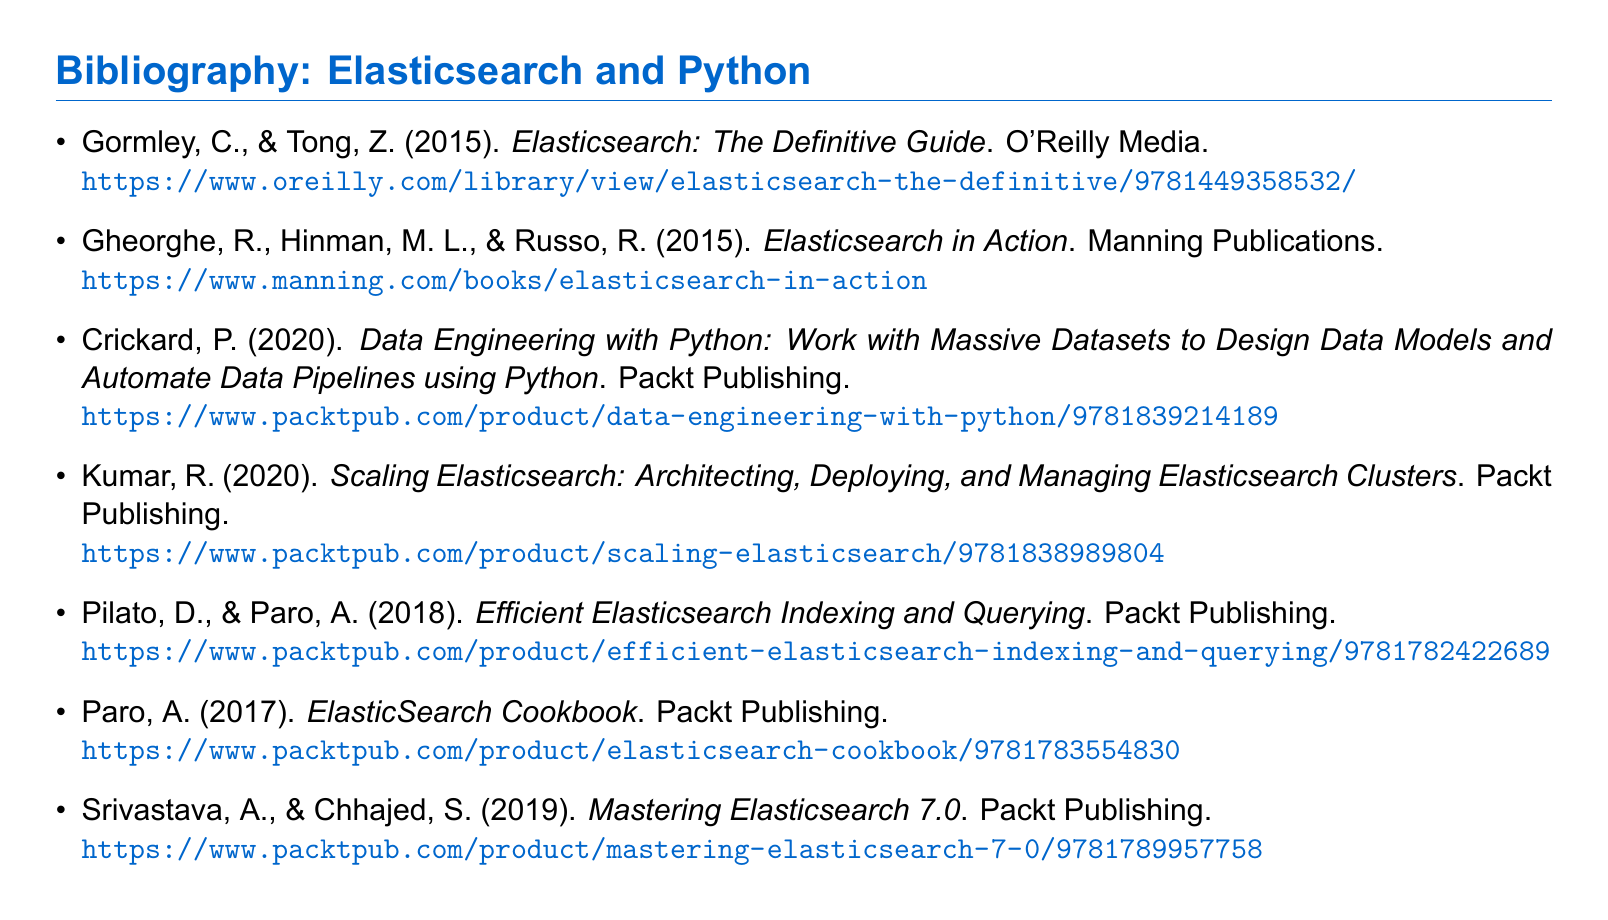What is the title of the first book listed? The first book listed is "Elasticsearch: The Definitive Guide".
Answer: Elasticsearch: The Definitive Guide Who are the authors of "Efficient Elasticsearch Indexing and Querying"? The authors are D. Pilato and A. Paro.
Answer: D. Pilato and A. Paro What year was "Scaling Elasticsearch" published? "Scaling Elasticsearch" was published in 2020.
Answer: 2020 How many books listed are published by Packt Publishing? There are four books published by Packt Publishing in the list.
Answer: four Which book has a URL that includes "manning"? The book is "Elasticsearch in Action".
Answer: Elasticsearch in Action What is the common subject of the bibliography? The common subject is Elasticsearch and Python.
Answer: Elasticsearch and Python What type of document is presented? The document is a bibliography.
Answer: bibliography Name the publisher of the book "Data Engineering with Python". The publisher is Packt Publishing.
Answer: Packt Publishing 